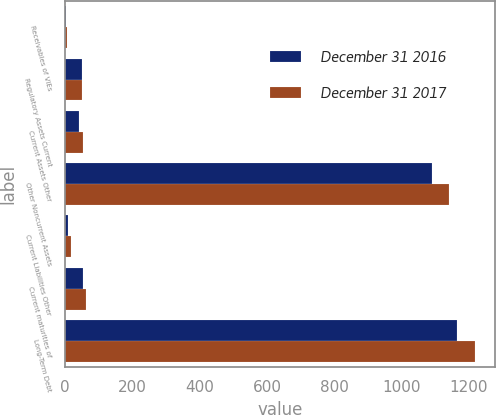Convert chart to OTSL. <chart><loc_0><loc_0><loc_500><loc_500><stacked_bar_chart><ecel><fcel>Receivables of VIEs<fcel>Regulatory Assets Current<fcel>Current Assets Other<fcel>Other Noncurrent Assets<fcel>Current Liabilities Other<fcel>Current maturities of<fcel>Long-Term Debt<nl><fcel>December 31 2016<fcel>4<fcel>51<fcel>40<fcel>1091<fcel>10<fcel>53<fcel>1164<nl><fcel>December 31 2017<fcel>6<fcel>50<fcel>53<fcel>1142<fcel>17<fcel>62<fcel>1217<nl></chart> 